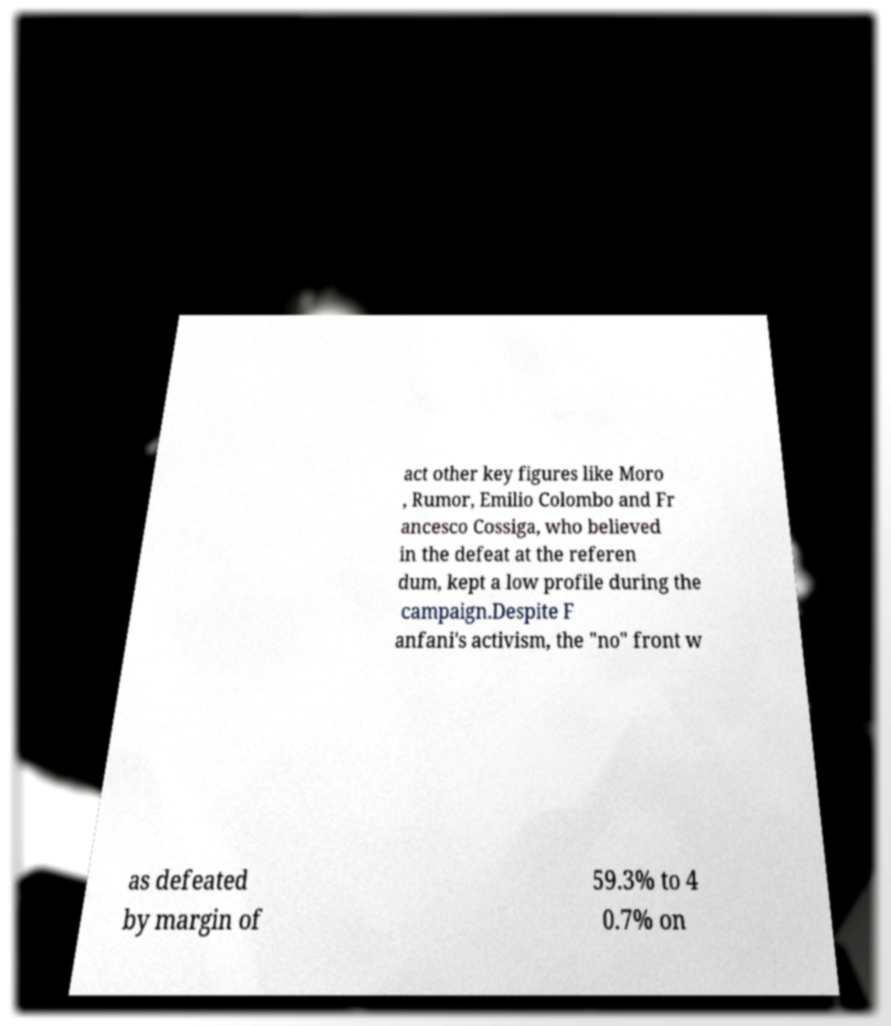Can you read and provide the text displayed in the image?This photo seems to have some interesting text. Can you extract and type it out for me? act other key figures like Moro , Rumor, Emilio Colombo and Fr ancesco Cossiga, who believed in the defeat at the referen dum, kept a low profile during the campaign.Despite F anfani's activism, the "no" front w as defeated by margin of 59.3% to 4 0.7% on 